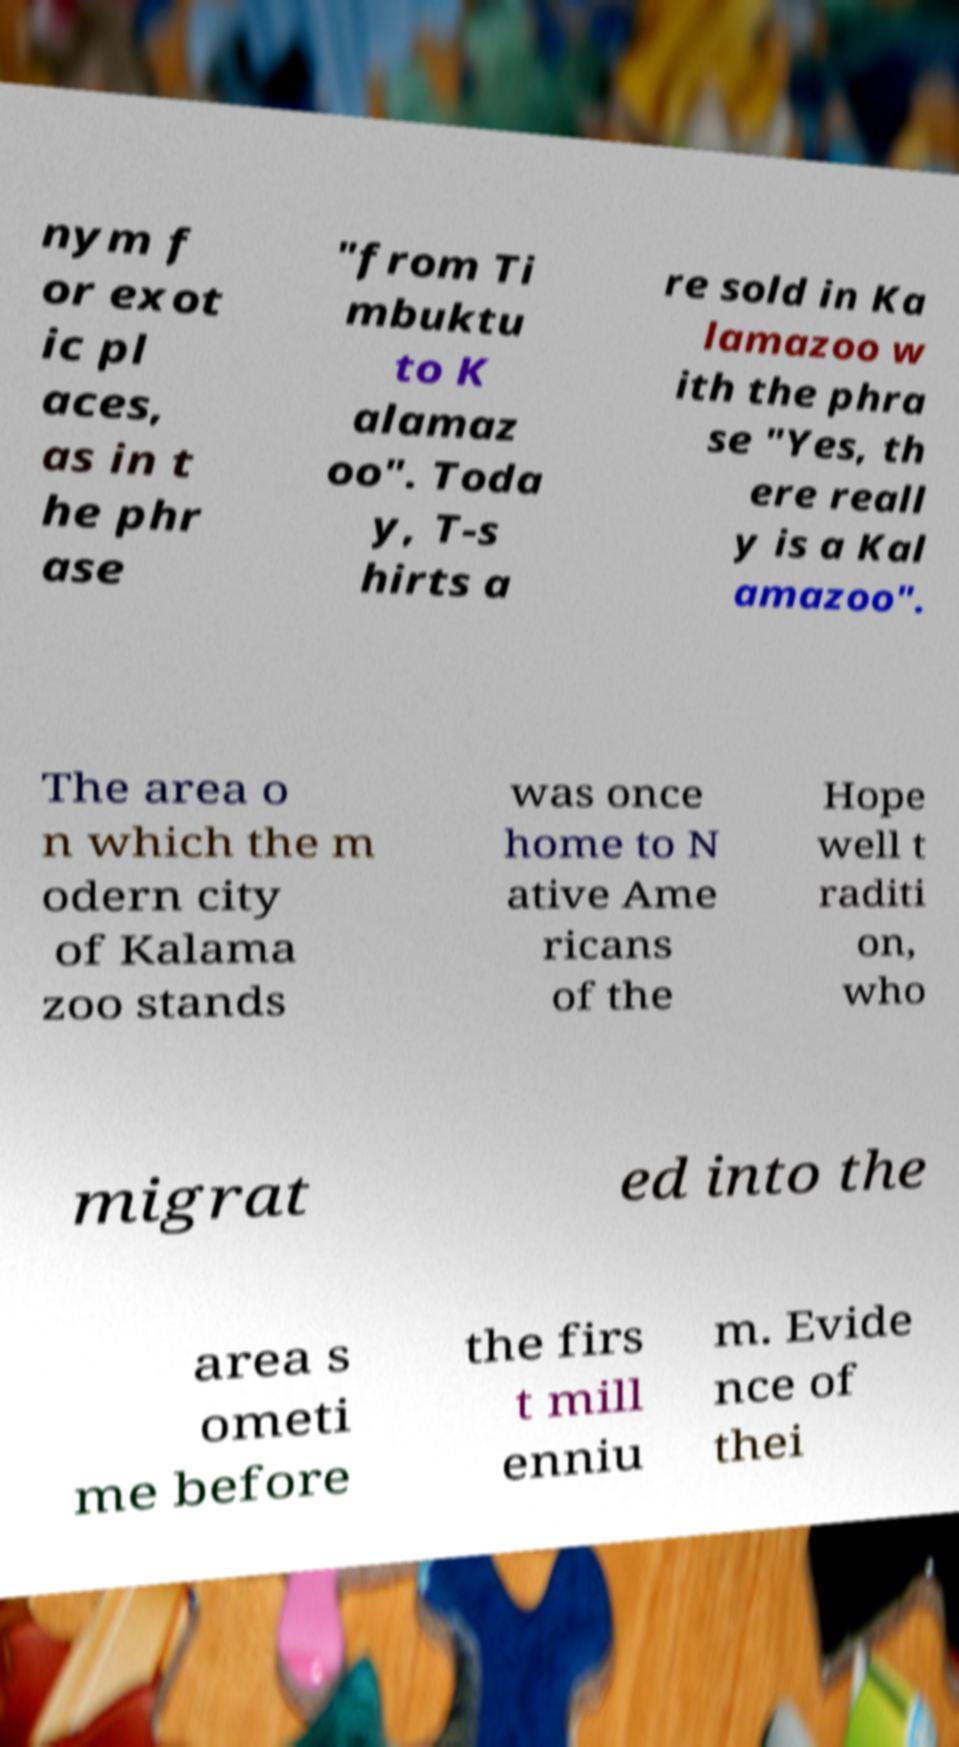What messages or text are displayed in this image? I need them in a readable, typed format. nym f or exot ic pl aces, as in t he phr ase "from Ti mbuktu to K alamaz oo". Toda y, T-s hirts a re sold in Ka lamazoo w ith the phra se "Yes, th ere reall y is a Kal amazoo". The area o n which the m odern city of Kalama zoo stands was once home to N ative Ame ricans of the Hope well t raditi on, who migrat ed into the area s ometi me before the firs t mill enniu m. Evide nce of thei 